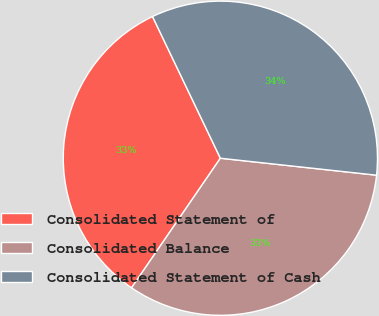<chart> <loc_0><loc_0><loc_500><loc_500><pie_chart><fcel>Consolidated Statement of<fcel>Consolidated Balance<fcel>Consolidated Statement of Cash<nl><fcel>33.33%<fcel>32.84%<fcel>33.83%<nl></chart> 